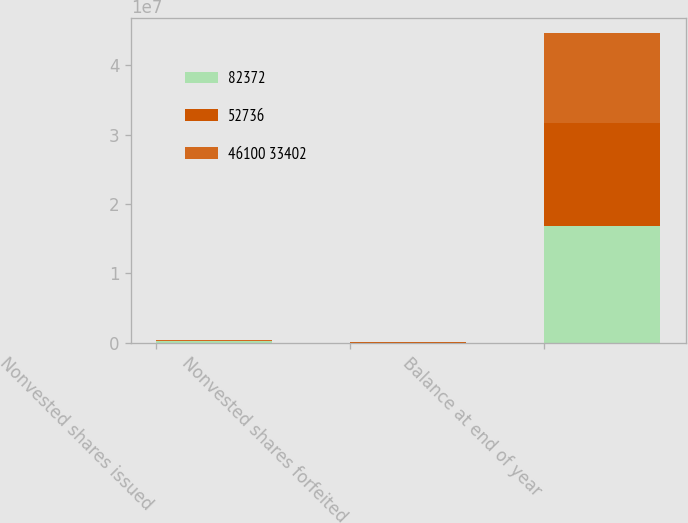<chart> <loc_0><loc_0><loc_500><loc_500><stacked_bar_chart><ecel><fcel>Nonvested shares issued<fcel>Nonvested shares forfeited<fcel>Balance at end of year<nl><fcel>82372<fcel>179309<fcel>3858<fcel>1.67456e+07<nl><fcel>52736<fcel>62936<fcel>1909<fcel>1.4891e+07<nl><fcel>46100 33402<fcel>121865<fcel>38266<fcel>1.29599e+07<nl></chart> 